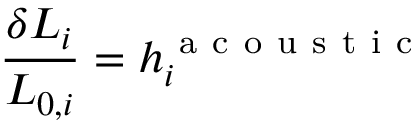Convert formula to latex. <formula><loc_0><loc_0><loc_500><loc_500>\frac { \delta L _ { i } } { L _ { 0 , i } } = h _ { i } ^ { a c o u s t i c }</formula> 